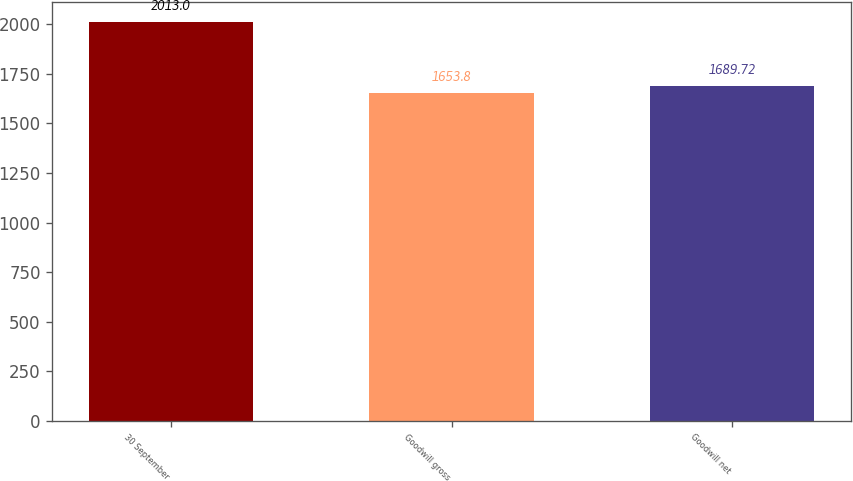<chart> <loc_0><loc_0><loc_500><loc_500><bar_chart><fcel>30 September<fcel>Goodwill gross<fcel>Goodwill net<nl><fcel>2013<fcel>1653.8<fcel>1689.72<nl></chart> 